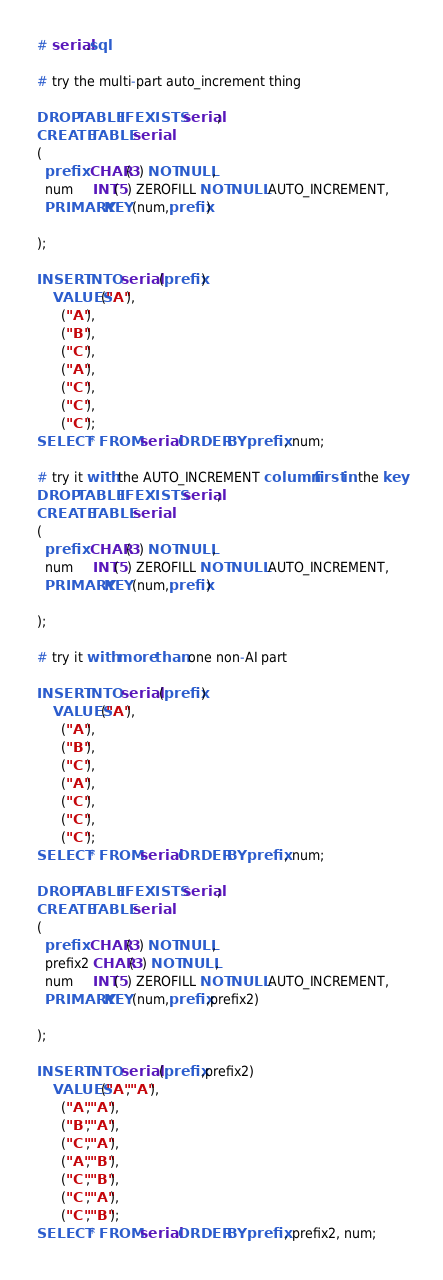<code> <loc_0><loc_0><loc_500><loc_500><_SQL_># serial.sql

# try the multi-part auto_increment thing

DROP TABLE IF EXISTS serial;
CREATE TABLE serial
(
  prefix  CHAR(3) NOT NULL,
  num     INT(5) ZEROFILL NOT NULL AUTO_INCREMENT,
  PRIMARY KEY (num,prefix)
  
);

INSERT INTO serial (prefix)
    VALUES("A"),
      ("A"),
      ("B"),
      ("C"),
      ("A"),
      ("C"),
      ("C"),
      ("C");
SELECT * FROM serial ORDER BY prefix, num;

# try it with the AUTO_INCREMENT column first in the key
DROP TABLE IF EXISTS serial;
CREATE TABLE serial
(
  prefix  CHAR(3) NOT NULL,
  num     INT(5) ZEROFILL NOT NULL AUTO_INCREMENT,
  PRIMARY KEY (num,prefix)
  
);

# try it with more than one non-AI part

INSERT INTO serial (prefix)
    VALUES("A"),
      ("A"),
      ("B"),
      ("C"),
      ("A"),
      ("C"),
      ("C"),
      ("C");
SELECT * FROM serial ORDER BY prefix, num;

DROP TABLE IF EXISTS serial;
CREATE TABLE serial
(
  prefix  CHAR(3) NOT NULL,
  prefix2 CHAR(3) NOT NULL,
  num     INT(5) ZEROFILL NOT NULL AUTO_INCREMENT,
  PRIMARY KEY (num,prefix,prefix2)
  
);

INSERT INTO serial (prefix,prefix2)
    VALUES("A","A"),
      ("A","A"),
      ("B","A"),
      ("C","A"),
      ("A","B"),
      ("C","B"),
      ("C","A"),
      ("C","B");
SELECT * FROM serial ORDER BY prefix, prefix2, num;
</code> 